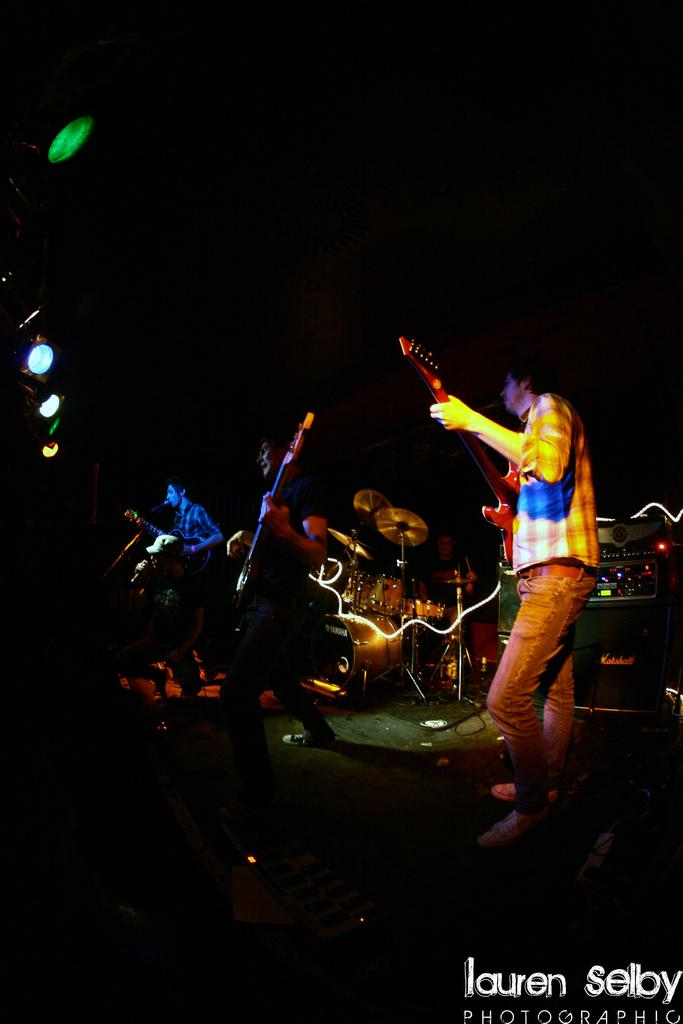What activity is the group of people in the image engaged in? The group of people in the image is playing music as a band. What instruments are the band members playing? The band members are playing guitars and drums. Who is providing vocals for the band? There is a person singing with a microphone. What can be seen on the left side of the image? Colorful lights are present on the left side of the image. What type of liquid is being poured from the microphone during the performance? There is no liquid being poured from the microphone during the performance; the person is singing with a microphone. 